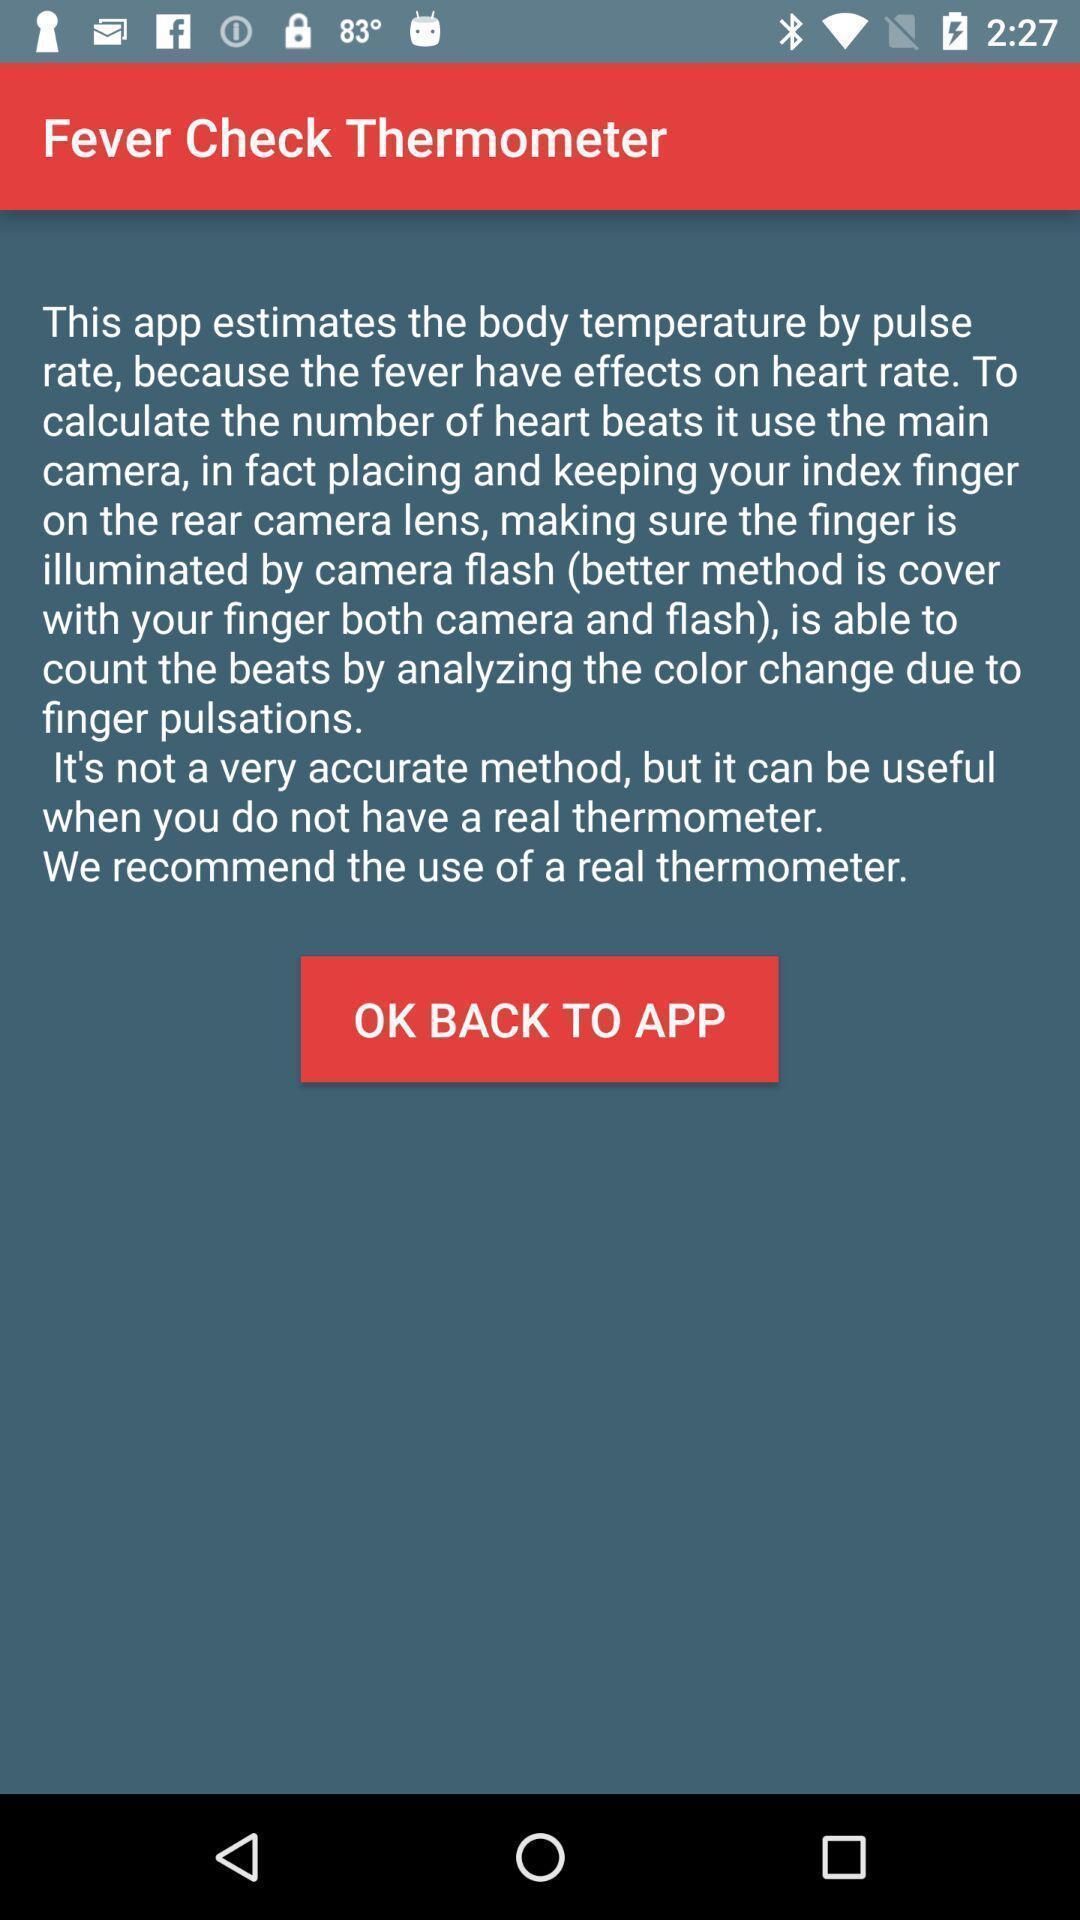Tell me about the visual elements in this screen capture. Page showing information about fever check thermometer. 